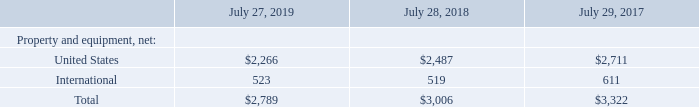(c) Additional Segment Information
The majority of our assets as of July 27, 2019 and July 28, 2018 were attributable to our U.S. operations. In fiscal 2019, 2018, and 2017, no single customer accounted for 10% or more of revenue.
Property and equipment information is based on the physical location of the assets. The following table presents property and equipment information for geographic areas (in millions):
Which years does the table provide information for the company's property and equipment based on the physical location of the assets? 2019, 2018, 2017. What was the net property and equipment from United States in 2019?
Answer scale should be: million. 2,266. What was the net property and equipment from International regions in 2018?
Answer scale should be: million. 519. What was the change in net property and equipment from United States between 2017 and 2018?
Answer scale should be: million. 2,487-2,711
Answer: -224. What was the change in net property and equipment from International regions between 2017 and 2018?
Answer scale should be: million. 519-611
Answer: -92. What was the percentage change in the total net property and equipment between 2018 and 2019?
Answer scale should be: percent. (2,789-3,006)/3,006
Answer: -7.22. 